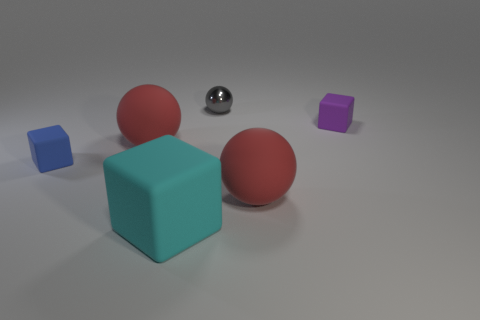What number of red rubber cubes have the same size as the blue matte block? There are two red rubber cubes in the image, and both are identical in size to the blue matte block. 